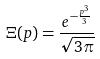<formula> <loc_0><loc_0><loc_500><loc_500>\Xi ( p ) = \frac { e ^ { - \frac { p ^ { 3 } } { 3 } } } { \sqrt { 3 \pi } }</formula> 